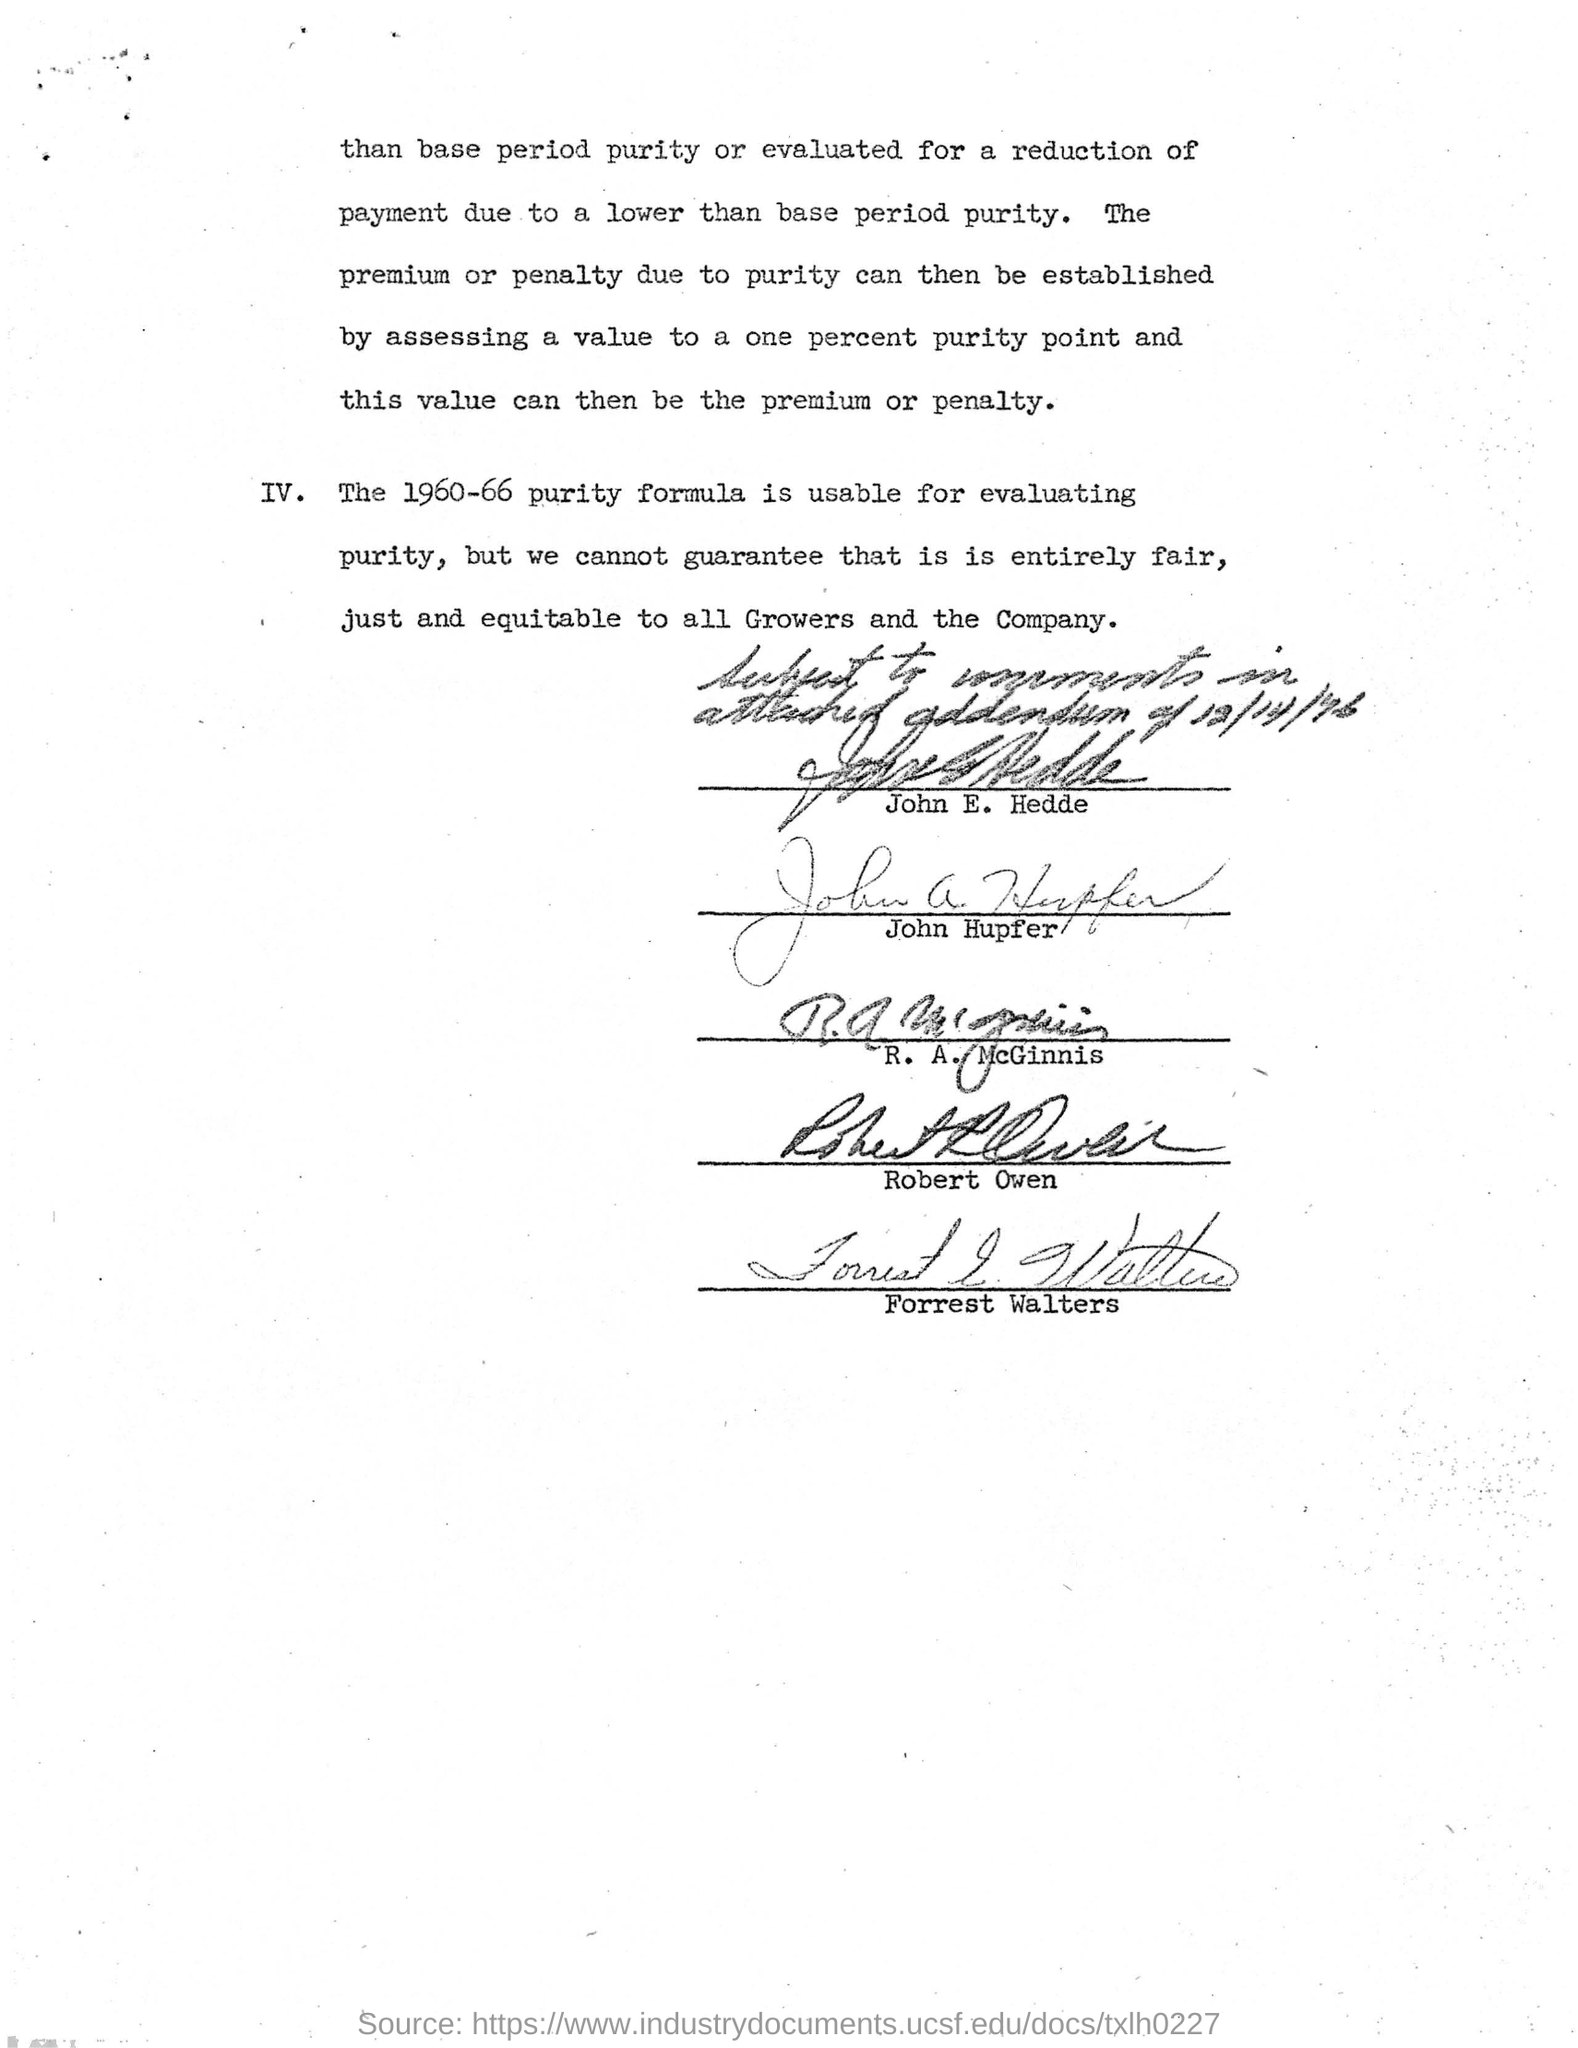What is 1960-66 purity formula usable for?
Your answer should be very brief. For evaluating purity. Who has undersigned at the very first of the document?
Offer a very short reply. John E. Hedde. 